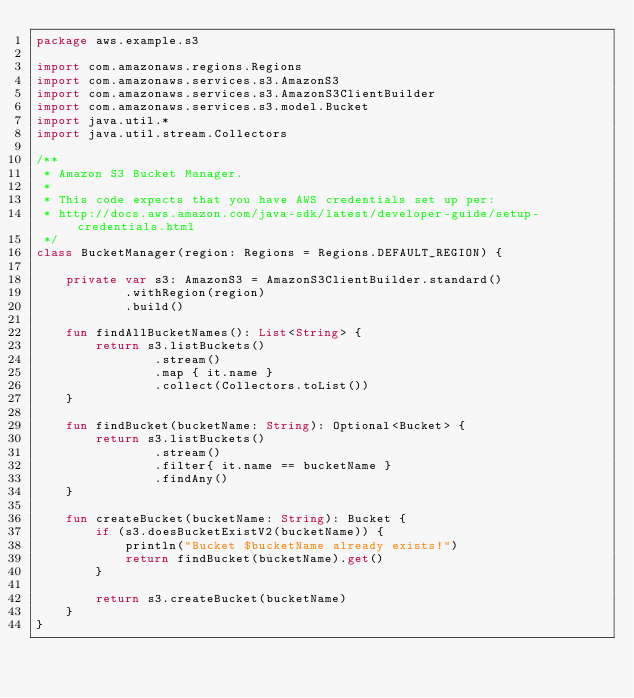<code> <loc_0><loc_0><loc_500><loc_500><_Kotlin_>package aws.example.s3

import com.amazonaws.regions.Regions
import com.amazonaws.services.s3.AmazonS3
import com.amazonaws.services.s3.AmazonS3ClientBuilder
import com.amazonaws.services.s3.model.Bucket
import java.util.*
import java.util.stream.Collectors

/**
 * Amazon S3 Bucket Manager.
 *
 * This code expects that you have AWS credentials set up per:
 * http://docs.aws.amazon.com/java-sdk/latest/developer-guide/setup-credentials.html
 */
class BucketManager(region: Regions = Regions.DEFAULT_REGION) {

    private var s3: AmazonS3 = AmazonS3ClientBuilder.standard()
            .withRegion(region)
            .build()

    fun findAllBucketNames(): List<String> {
        return s3.listBuckets()
                .stream()
                .map { it.name }
                .collect(Collectors.toList())
    }

    fun findBucket(bucketName: String): Optional<Bucket> {
        return s3.listBuckets()
                .stream()
                .filter{ it.name == bucketName }
                .findAny()
    }

    fun createBucket(bucketName: String): Bucket {
        if (s3.doesBucketExistV2(bucketName)) {
            println("Bucket $bucketName already exists!")
            return findBucket(bucketName).get()
        }

        return s3.createBucket(bucketName)
    }
}</code> 